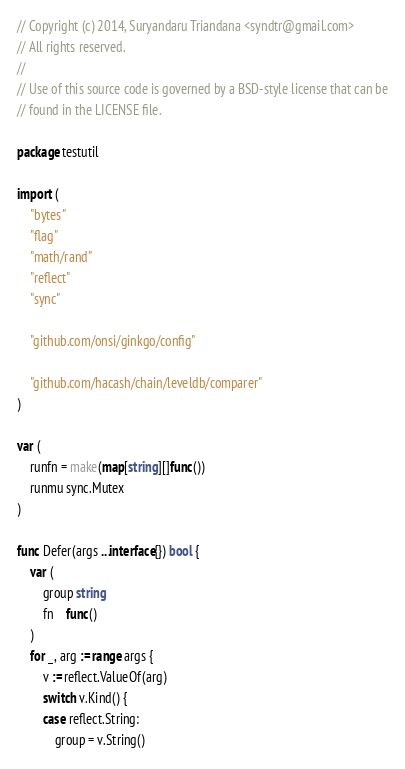Convert code to text. <code><loc_0><loc_0><loc_500><loc_500><_Go_>// Copyright (c) 2014, Suryandaru Triandana <syndtr@gmail.com>
// All rights reserved.
//
// Use of this source code is governed by a BSD-style license that can be
// found in the LICENSE file.

package testutil

import (
	"bytes"
	"flag"
	"math/rand"
	"reflect"
	"sync"

	"github.com/onsi/ginkgo/config"

	"github.com/hacash/chain/leveldb/comparer"
)

var (
	runfn = make(map[string][]func())
	runmu sync.Mutex
)

func Defer(args ...interface{}) bool {
	var (
		group string
		fn    func()
	)
	for _, arg := range args {
		v := reflect.ValueOf(arg)
		switch v.Kind() {
		case reflect.String:
			group = v.String()</code> 